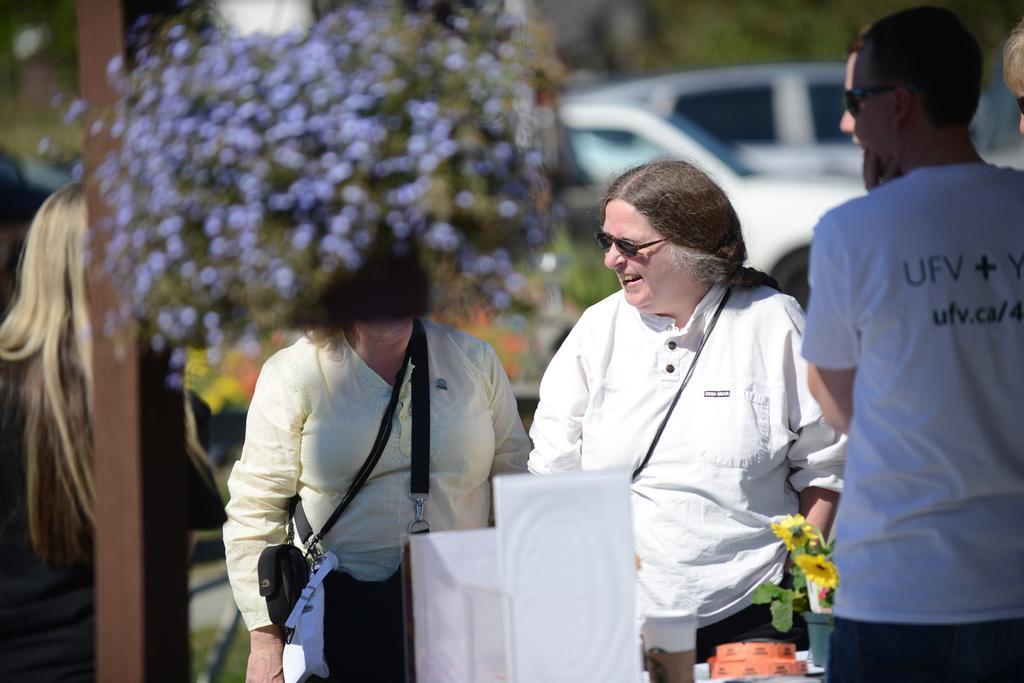Could you give a brief overview of what you see in this image? In the picture I can see people are standing on the ground. I can also see flowers and some other objects. In the background I can see a pole and vehicles. The background of the image is blurred. 